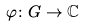Convert formula to latex. <formula><loc_0><loc_0><loc_500><loc_500>\varphi \colon G \to \mathbb { C }</formula> 